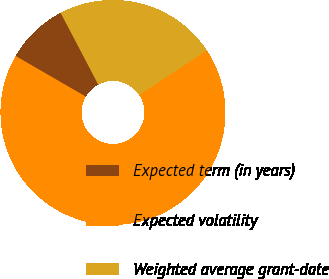Convert chart. <chart><loc_0><loc_0><loc_500><loc_500><pie_chart><fcel>Expected term (in years)<fcel>Expected volatility<fcel>Weighted average grant-date<nl><fcel>8.95%<fcel>67.67%<fcel>23.37%<nl></chart> 